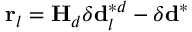Convert formula to latex. <formula><loc_0><loc_0><loc_500><loc_500>r _ { l } = H _ { d } \delta d _ { l } ^ { * d } - \delta d ^ { * }</formula> 